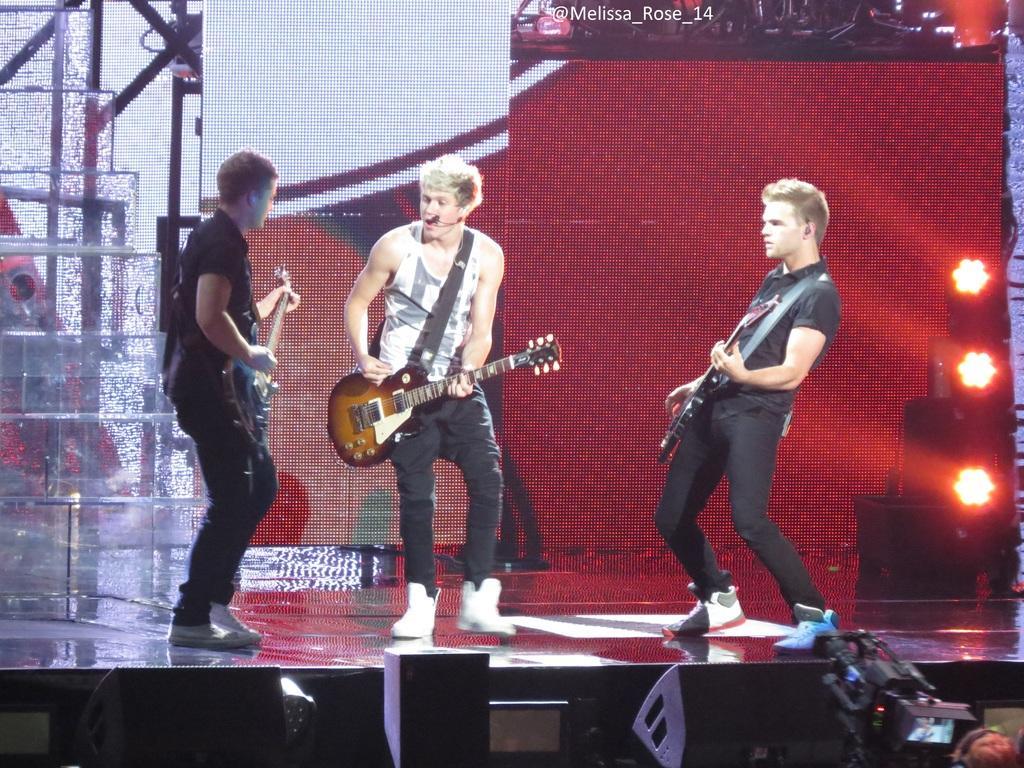Can you describe this image briefly? This picture is clicked in a musical concert. Here, we see three men standing on the stage. All the three of them are holding guitar in their hands and playing it. Man in middle of the picture wearing white T-shirt is also singing on microphone. Behind them, we see background which is white in color. 